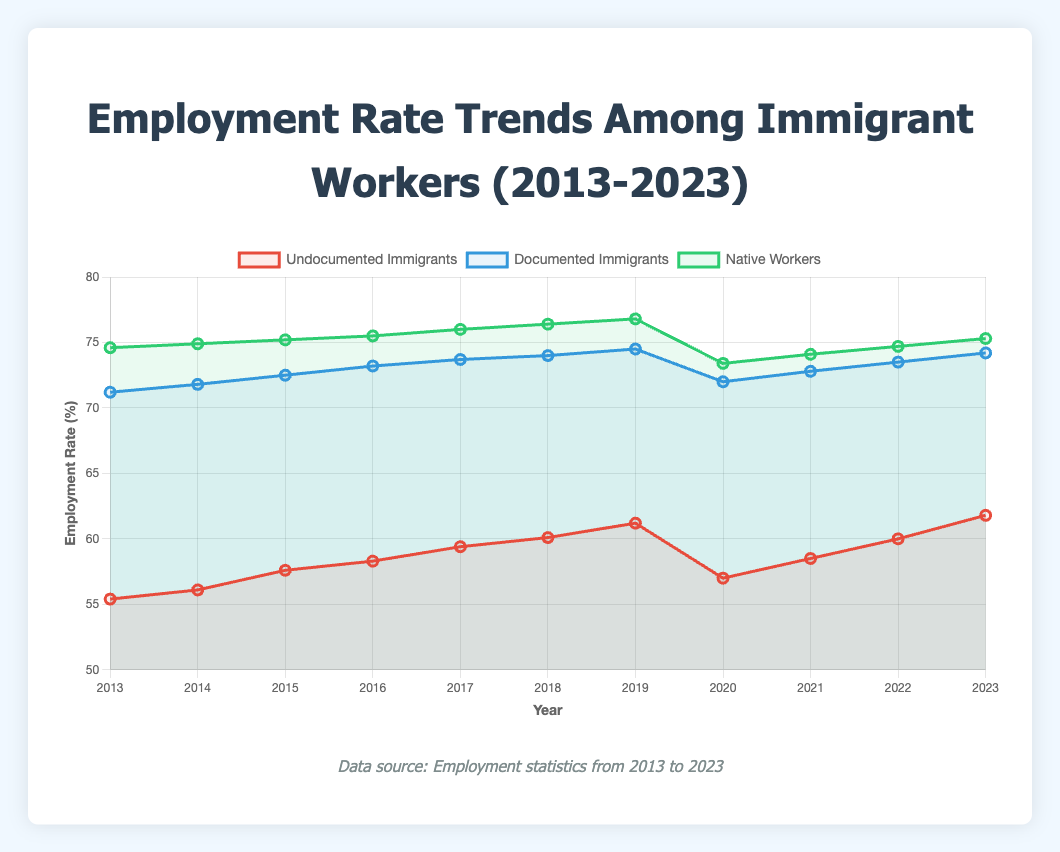What is the overall trend in the employment rate of undocumented immigrants from 2013 to 2023? The employment rate of undocumented immigrants shows an overall increasing trend from 55.4% in 2013 to 61.8% in 2023, with a dip in 2020.
Answer: Increasing How did the employment rate of native workers compare to that of documented immigrants in 2019? In 2019, the employment rate of native workers was 76.8%, and the employment rate of documented immigrants was 74.5%. Comparing these two values shows that native workers had a higher employment rate.
Answer: Native workers had a higher employment rate What year did the employment rate of undocumented immigrants see the most significant drop, and what was the new rate? The largest drop occurred in 2020 when the employment rate of undocumented immigrants fell from 61.2% in 2019 to 57.0% in 2020, a decrease of 4.2 percentage points.
Answer: 2020, 57.0% How much did the employment rate of documented immigrants change from 2016 to 2023? The employment rate of documented immigrants in 2016 was 73.2%, and in 2023, it was 74.2%. The change is calculated as 74.2% - 73.2% = 1.0%.
Answer: 1.0% In which year did the employment rate of native workers peak, and what was the rate? The employment rate of native workers peaked in 2019 at 76.8%.
Answer: 2019, 76.8% How does the employment rate of documented immigrants in 2020 compare to their employment rate in 2013? The employment rate of documented immigrants was 71.2% in 2013 and dropped to 72.0% in 2020. Therefore, there is a slight increase of 0.8 percentage points.
Answer: Slight increase Between 2019 and 2023, which group experienced the most significant increase in employment rate, and by how much? Undocumented immigrants saw the most significant increase in employment rate from 61.2% in 2019 to 61.8% in 2023, which is an increase of 0.6 percentage points. Documented immigrants saw an increase from 74.5% to 74.2% (a decrease actually) and native workers increased from 76.8% to 75.3% (another decrease).
Answer: Undocumented immigrants, 0.6% What was the employment rate difference between native workers and undocumented immigrants in 2021? In 2021, the employment rate of native workers was 74.1% and that of undocumented immigrants was 58.5%. The difference is 74.1% - 58.5% = 15.6%.
Answer: 15.6% How did the employment rate of undocumented immigrants trend between 2018 and 2020? The employment rate increased from 60.1% in 2018 to 61.2% in 2019, then dropped to 57.0% in 2020.
Answer: Increased then decreased Between 2020 and 2023, which group saw the highest recovery in their employment rate? Undocumented immigrants' employment rate increased from 57.0% in 2020 to 61.8% in 2023, a recovery of 4.8 percentage points. Documented immigrants increased from 72.0% to 74.2% (2.2 percentage points) and native workers increased from 73.4% to 75.3% (1.9 percentage points).
Answer: Undocumented immigrants, 4.8% 